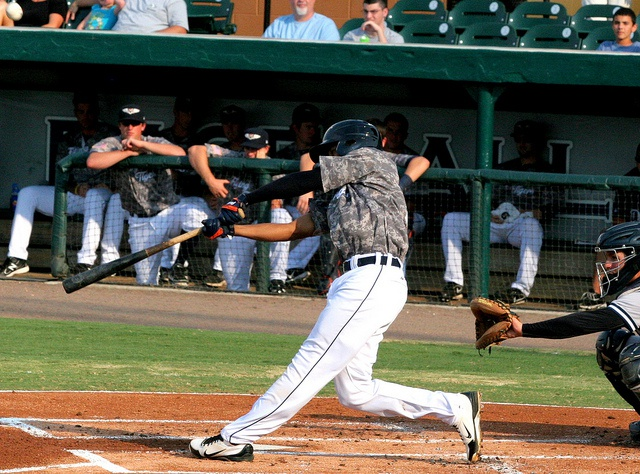Describe the objects in this image and their specific colors. I can see people in salmon, white, black, darkgray, and gray tones, people in salmon, black, teal, gray, and lightgray tones, people in salmon, black, gray, maroon, and lightgray tones, people in salmon, black, gray, and darkgray tones, and people in salmon, black, gray, and lightgray tones in this image. 